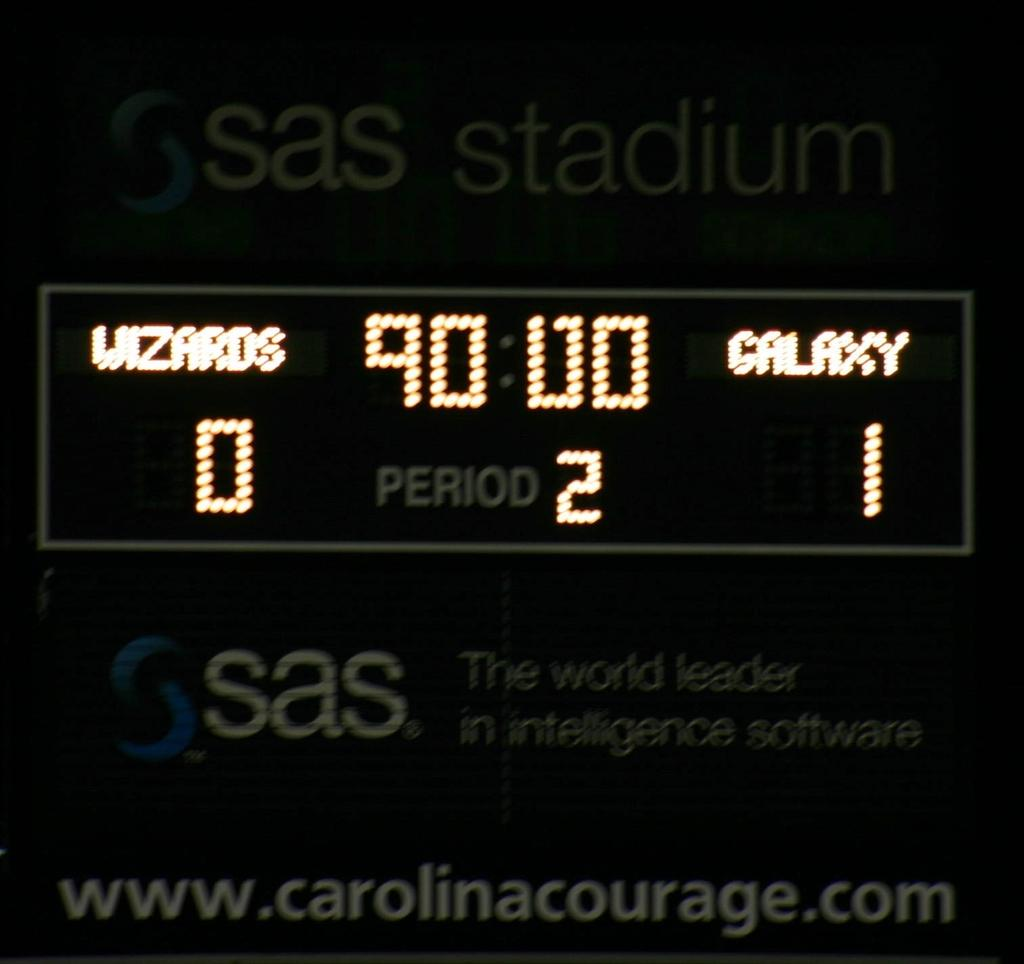<image>
Present a compact description of the photo's key features. a scoreboard that has the number 2 on it 